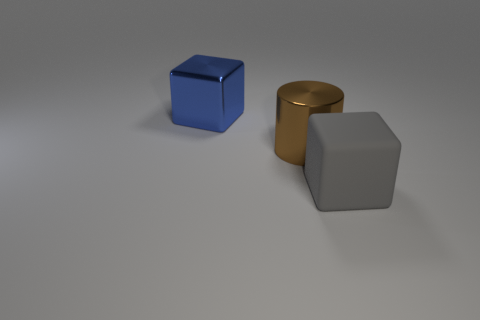Are there any other things that are the same size as the brown metal cylinder?
Provide a short and direct response. Yes. There is a gray rubber thing; are there any blue cubes to the left of it?
Keep it short and to the point. Yes. Do the large block behind the gray matte cube and the block to the right of the blue cube have the same color?
Make the answer very short. No. Is there a large brown shiny thing that has the same shape as the large blue thing?
Your answer should be very brief. No. How many other things are the same color as the large shiny cylinder?
Keep it short and to the point. 0. The metallic object that is right of the big cube behind the cube in front of the big shiny cube is what color?
Ensure brevity in your answer.  Brown. Is the number of large cylinders that are in front of the gray cube the same as the number of brown metal things?
Keep it short and to the point. No. There is a metallic object that is in front of the blue block; is its size the same as the large matte object?
Give a very brief answer. Yes. What number of gray matte cubes are there?
Provide a succinct answer. 1. How many cubes are both on the right side of the big blue thing and behind the gray cube?
Offer a terse response. 0. 